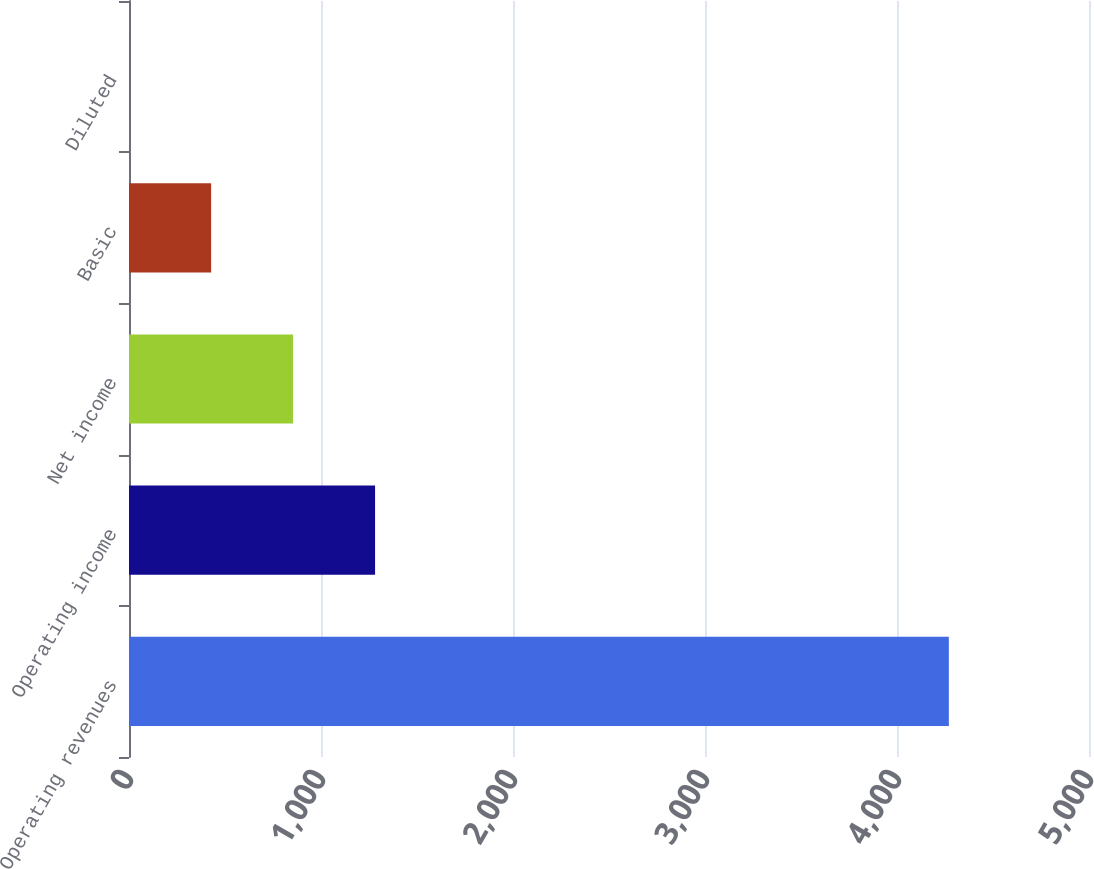Convert chart to OTSL. <chart><loc_0><loc_0><loc_500><loc_500><bar_chart><fcel>Operating revenues<fcel>Operating income<fcel>Net income<fcel>Basic<fcel>Diluted<nl><fcel>4270<fcel>1281.59<fcel>854.67<fcel>427.76<fcel>0.85<nl></chart> 